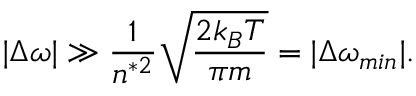Convert formula to latex. <formula><loc_0><loc_0><loc_500><loc_500>| \Delta \omega | \gg \frac { 1 } { n ^ { * 2 } } \sqrt { \frac { 2 k _ { B } T } { \pi m } } = | \Delta \omega _ { \min } | .</formula> 